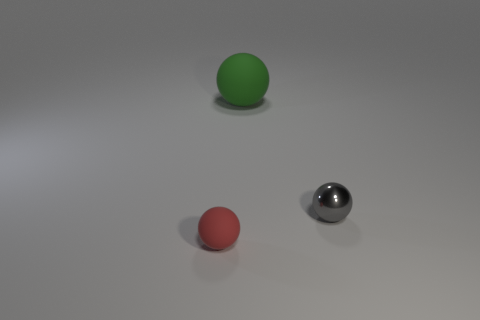Subtract all tiny spheres. How many spheres are left? 1 Subtract 1 spheres. How many spheres are left? 2 Subtract all gray spheres. How many spheres are left? 2 Add 3 small rubber objects. How many objects exist? 6 Subtract all cyan balls. Subtract all gray blocks. How many balls are left? 3 Subtract all tiny yellow matte balls. Subtract all large objects. How many objects are left? 2 Add 2 shiny objects. How many shiny objects are left? 3 Add 3 matte objects. How many matte objects exist? 5 Subtract 0 blue spheres. How many objects are left? 3 